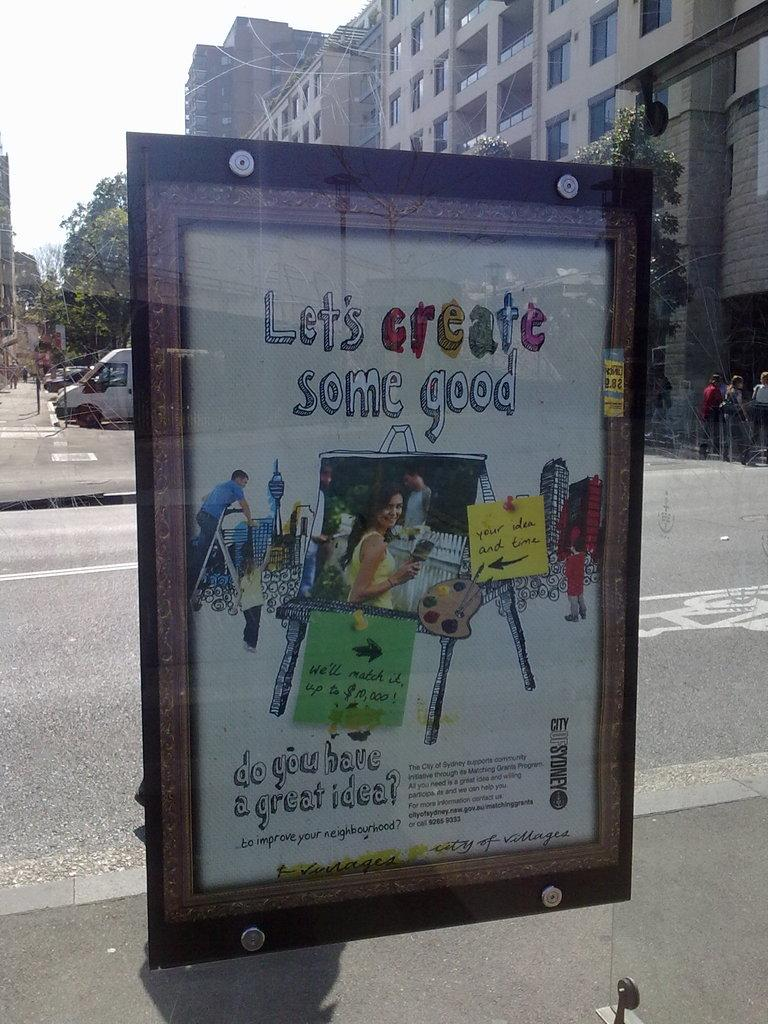<image>
Share a concise interpretation of the image provided. Poster on a window that says "Let's create some good" on the top. 